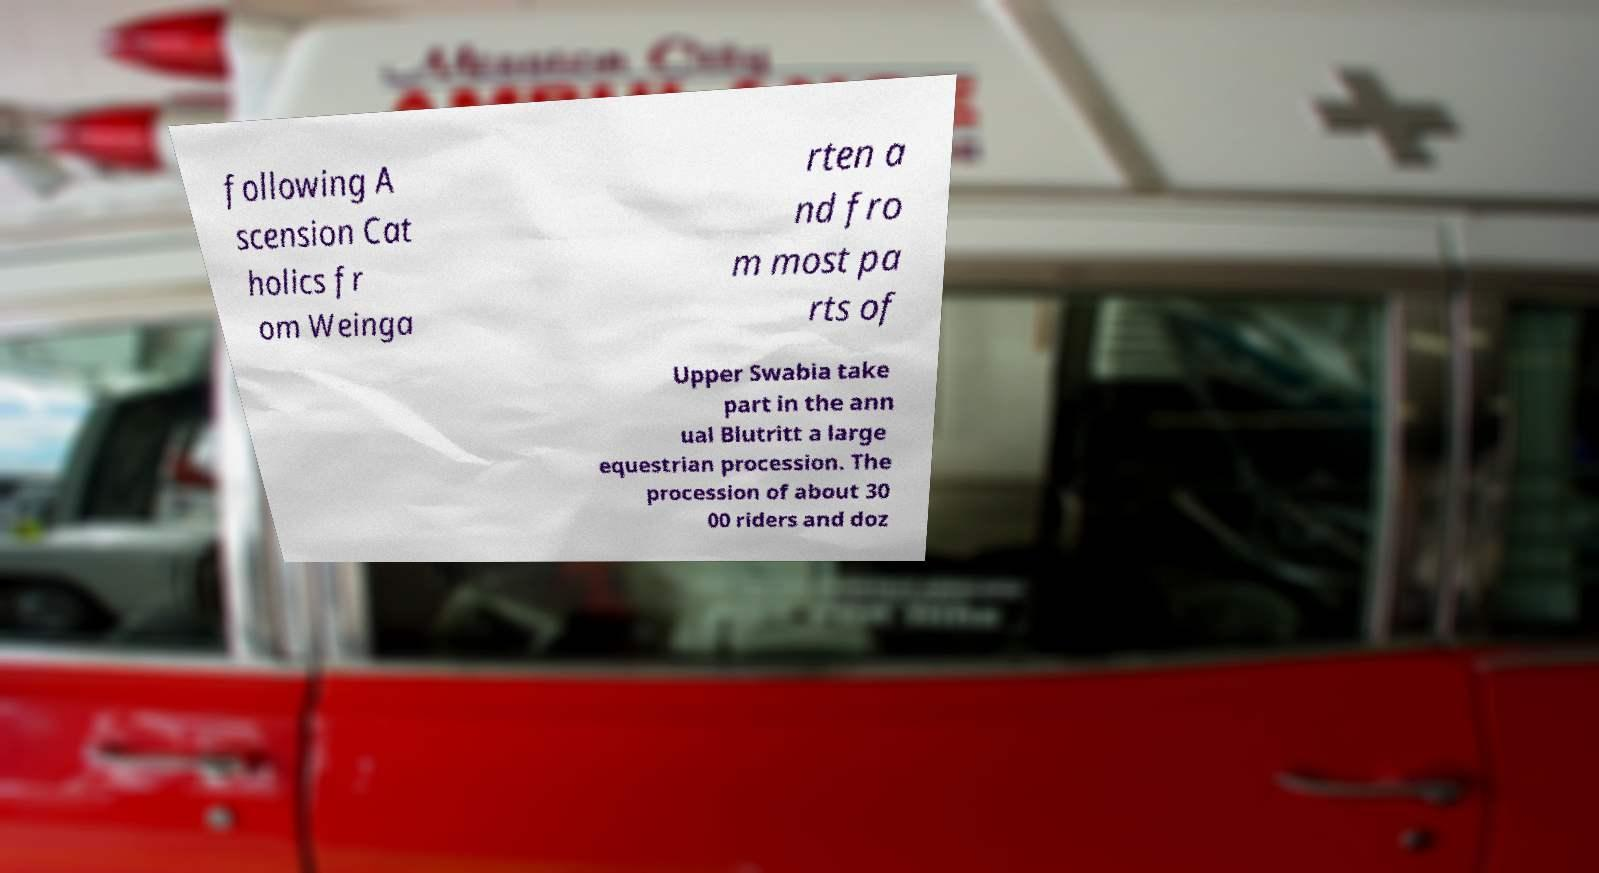Please identify and transcribe the text found in this image. following A scension Cat holics fr om Weinga rten a nd fro m most pa rts of Upper Swabia take part in the ann ual Blutritt a large equestrian procession. The procession of about 30 00 riders and doz 